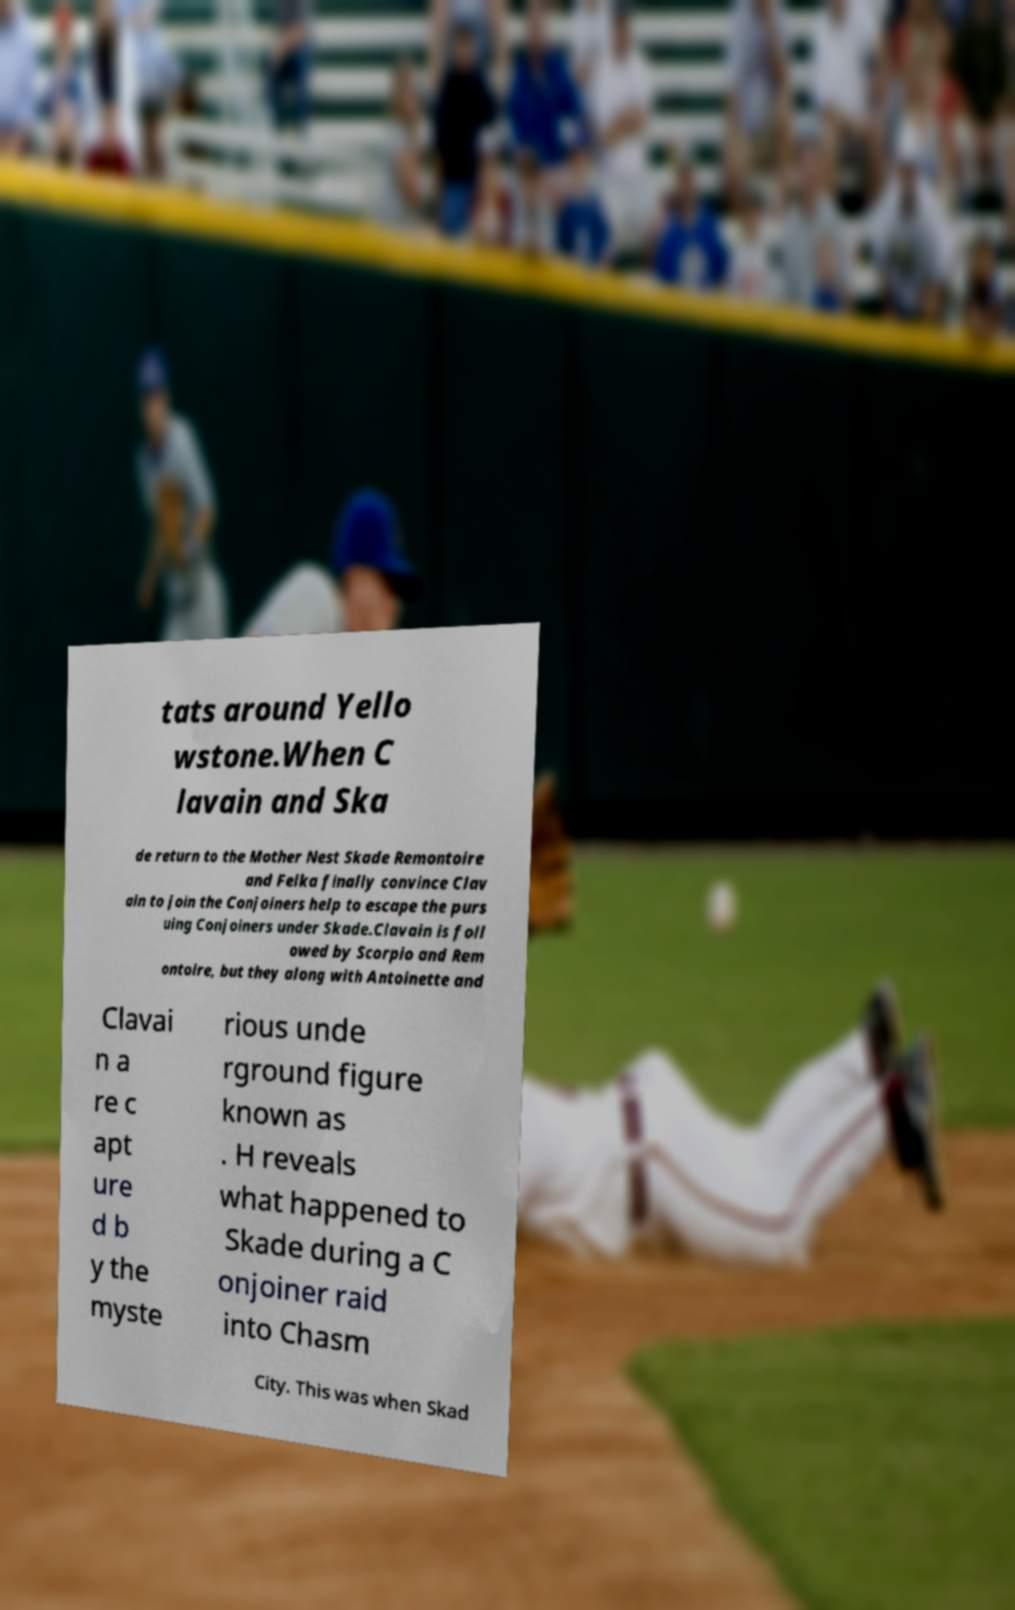Can you accurately transcribe the text from the provided image for me? tats around Yello wstone.When C lavain and Ska de return to the Mother Nest Skade Remontoire and Felka finally convince Clav ain to join the Conjoiners help to escape the purs uing Conjoiners under Skade.Clavain is foll owed by Scorpio and Rem ontoire, but they along with Antoinette and Clavai n a re c apt ure d b y the myste rious unde rground figure known as . H reveals what happened to Skade during a C onjoiner raid into Chasm City. This was when Skad 